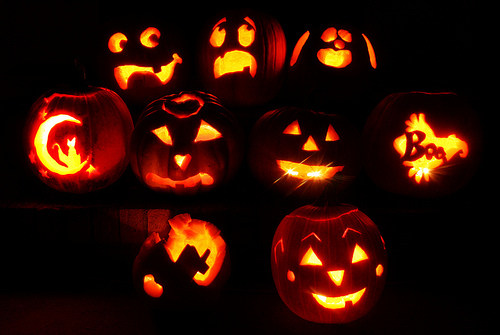<image>
Is there a fire on the pumpkin? No. The fire is not positioned on the pumpkin. They may be near each other, but the fire is not supported by or resting on top of the pumpkin. Is the moon in the pumpkin? Yes. The moon is contained within or inside the pumpkin, showing a containment relationship. Is the boo next to the fifth? No. The boo is not positioned next to the fifth. They are located in different areas of the scene. 